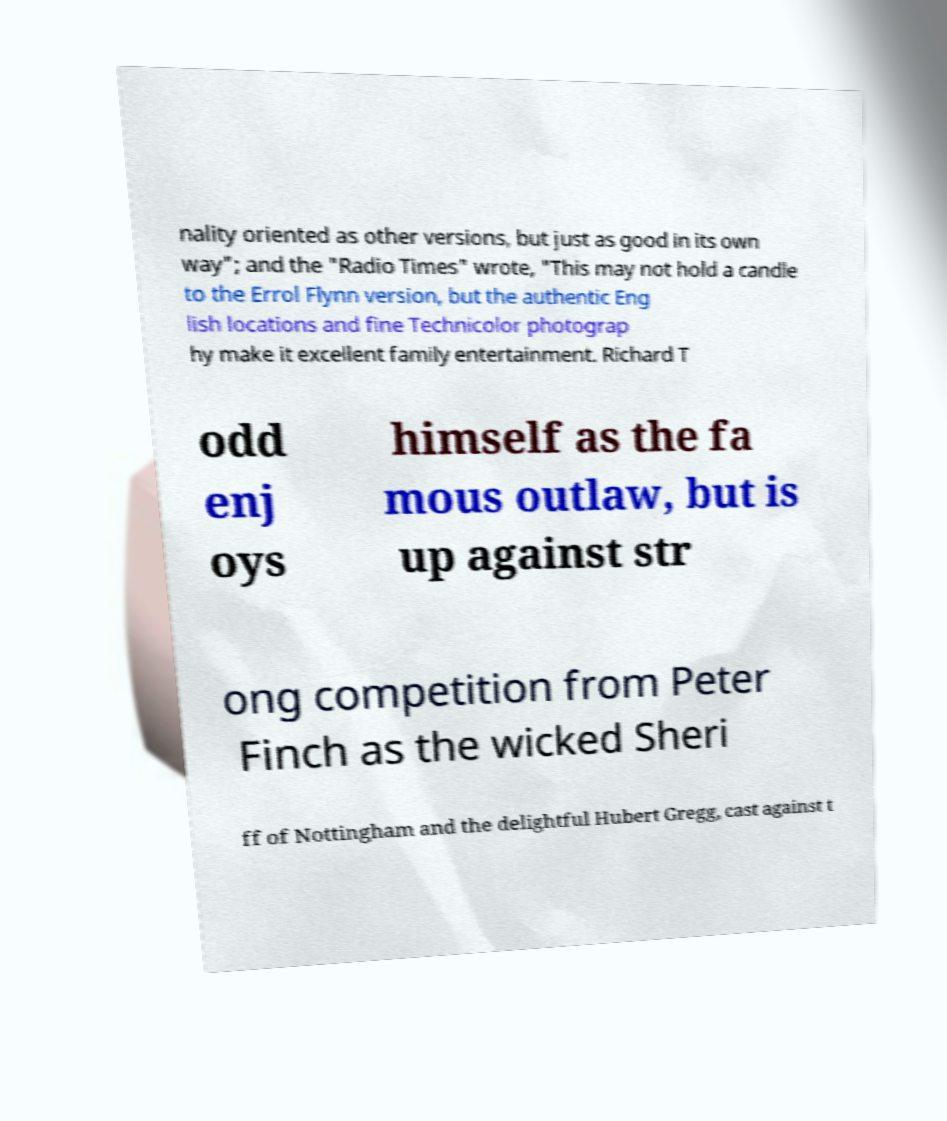There's text embedded in this image that I need extracted. Can you transcribe it verbatim? nality oriented as other versions, but just as good in its own way"; and the "Radio Times" wrote, "This may not hold a candle to the Errol Flynn version, but the authentic Eng lish locations and fine Technicolor photograp hy make it excellent family entertainment. Richard T odd enj oys himself as the fa mous outlaw, but is up against str ong competition from Peter Finch as the wicked Sheri ff of Nottingham and the delightful Hubert Gregg, cast against t 